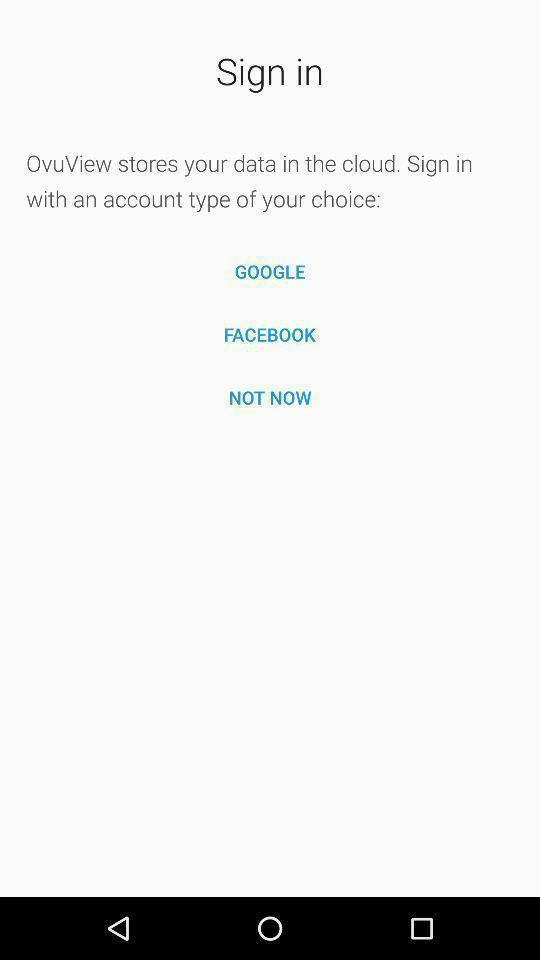Provide a detailed account of this screenshot. Sign-in page with selective social app on health app. 